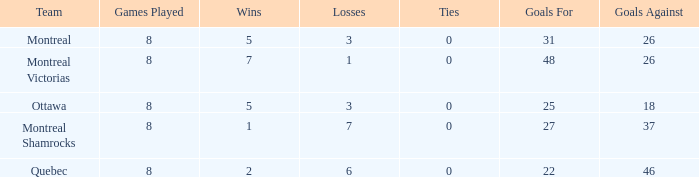For teams with more than 0 ties and goals against of 37, how many wins were tallied? None. 